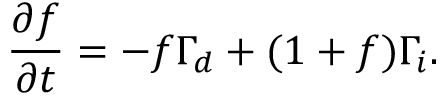Convert formula to latex. <formula><loc_0><loc_0><loc_500><loc_500>\frac { \partial f } { \partial t } = - f \Gamma _ { d } + ( 1 + f ) \Gamma _ { i } .</formula> 